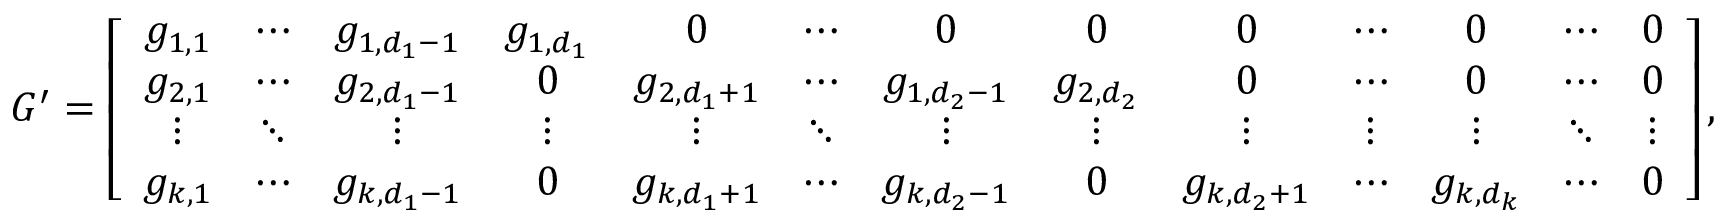Convert formula to latex. <formula><loc_0><loc_0><loc_500><loc_500>G ^ { \prime } = \left [ \begin{array} { c c c c c c c c c c c c c } { g _ { 1 , 1 } } & { \cdots } & { g _ { 1 , d _ { 1 } - 1 } } & { g _ { 1 , d _ { 1 } } } & { 0 } & { \cdots } & { 0 } & { 0 } & { 0 } & { \cdots } & { 0 } & { \cdots } & { 0 } \\ { g _ { 2 , 1 } } & { \cdots } & { g _ { 2 , d _ { 1 } - 1 } } & { 0 } & { g _ { 2 , d _ { 1 } + 1 } } & { \cdots } & { g _ { 1 , d _ { 2 } - 1 } } & { g _ { 2 , d _ { 2 } } } & { 0 } & { \cdots } & { 0 } & { \cdots } & { 0 } \\ { \vdots } & { \ddots } & { \vdots } & { \vdots } & { \vdots } & { \ddots } & { \vdots } & { \vdots } & { \vdots } & { \vdots } & { \vdots } & { \ddots } & { \vdots } \\ { g _ { k , 1 } } & { \cdots } & { g _ { k , d _ { 1 } - 1 } } & { 0 } & { g _ { k , d _ { 1 } + 1 } } & { \cdots } & { g _ { k , d _ { 2 } - 1 } } & { 0 } & { g _ { k , d _ { 2 } + 1 } } & { \cdots } & { g _ { k , d _ { k } } } & { \cdots } & { 0 } \end{array} \right ] ,</formula> 